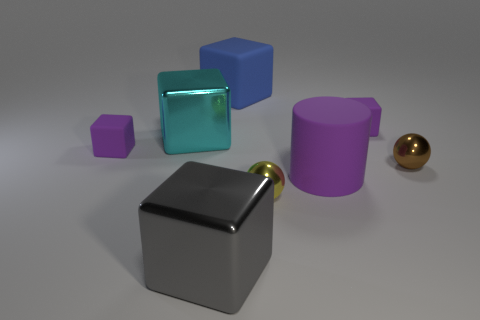There is a metal thing that is on the right side of the yellow metallic object that is to the right of the big metallic block behind the big cylinder; what is its size?
Your answer should be very brief. Small. Do the tiny cube left of the blue thing and the big object on the right side of the blue block have the same color?
Make the answer very short. Yes. Do the small rubber thing that is left of the big gray shiny cube and the big rubber cylinder have the same color?
Provide a short and direct response. Yes. There is a large object that is made of the same material as the cyan cube; what color is it?
Offer a very short reply. Gray. Do the blue rubber cube and the brown metallic ball have the same size?
Give a very brief answer. No. What is the material of the large purple cylinder?
Ensure brevity in your answer.  Rubber. What is the material of the other sphere that is the same size as the yellow shiny ball?
Make the answer very short. Metal. Are there any matte cylinders that have the same size as the yellow ball?
Your answer should be compact. No. Are there the same number of big blocks in front of the big rubber cylinder and shiny spheres to the left of the brown sphere?
Keep it short and to the point. Yes. Is the number of cyan objects greater than the number of small blue shiny cubes?
Give a very brief answer. Yes. 